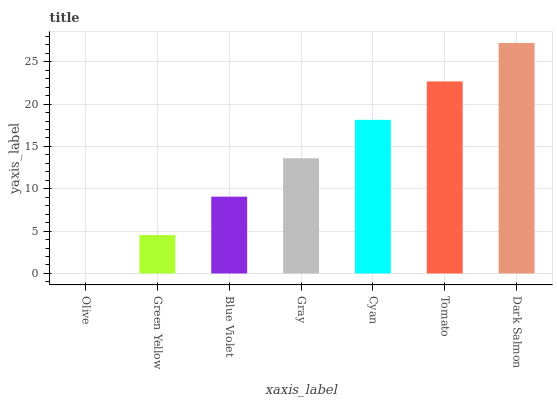Is Olive the minimum?
Answer yes or no. Yes. Is Dark Salmon the maximum?
Answer yes or no. Yes. Is Green Yellow the minimum?
Answer yes or no. No. Is Green Yellow the maximum?
Answer yes or no. No. Is Green Yellow greater than Olive?
Answer yes or no. Yes. Is Olive less than Green Yellow?
Answer yes or no. Yes. Is Olive greater than Green Yellow?
Answer yes or no. No. Is Green Yellow less than Olive?
Answer yes or no. No. Is Gray the high median?
Answer yes or no. Yes. Is Gray the low median?
Answer yes or no. Yes. Is Dark Salmon the high median?
Answer yes or no. No. Is Blue Violet the low median?
Answer yes or no. No. 